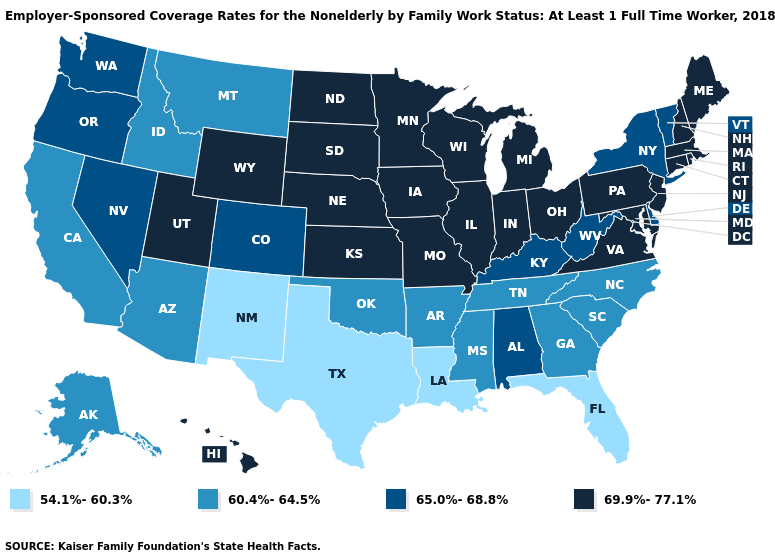What is the lowest value in states that border Missouri?
Give a very brief answer. 60.4%-64.5%. Does the map have missing data?
Be succinct. No. What is the highest value in the MidWest ?
Keep it brief. 69.9%-77.1%. What is the value of Maine?
Answer briefly. 69.9%-77.1%. Name the states that have a value in the range 65.0%-68.8%?
Be succinct. Alabama, Colorado, Delaware, Kentucky, Nevada, New York, Oregon, Vermont, Washington, West Virginia. What is the lowest value in the USA?
Be succinct. 54.1%-60.3%. Does New Hampshire have a higher value than New York?
Short answer required. Yes. Name the states that have a value in the range 54.1%-60.3%?
Be succinct. Florida, Louisiana, New Mexico, Texas. What is the value of California?
Keep it brief. 60.4%-64.5%. Name the states that have a value in the range 60.4%-64.5%?
Write a very short answer. Alaska, Arizona, Arkansas, California, Georgia, Idaho, Mississippi, Montana, North Carolina, Oklahoma, South Carolina, Tennessee. What is the value of Mississippi?
Give a very brief answer. 60.4%-64.5%. What is the value of Virginia?
Answer briefly. 69.9%-77.1%. Which states hav the highest value in the West?
Quick response, please. Hawaii, Utah, Wyoming. Name the states that have a value in the range 69.9%-77.1%?
Be succinct. Connecticut, Hawaii, Illinois, Indiana, Iowa, Kansas, Maine, Maryland, Massachusetts, Michigan, Minnesota, Missouri, Nebraska, New Hampshire, New Jersey, North Dakota, Ohio, Pennsylvania, Rhode Island, South Dakota, Utah, Virginia, Wisconsin, Wyoming. Does Virginia have the highest value in the South?
Write a very short answer. Yes. 